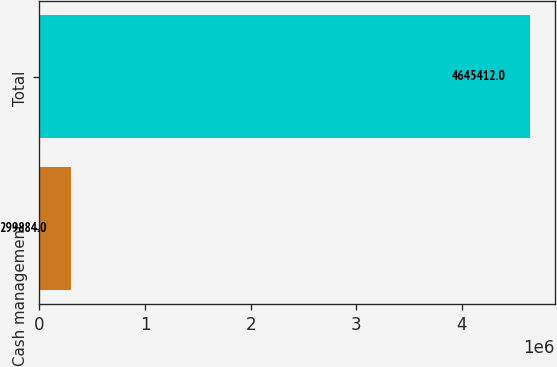Convert chart to OTSL. <chart><loc_0><loc_0><loc_500><loc_500><bar_chart><fcel>Cash management<fcel>Total<nl><fcel>299884<fcel>4.64541e+06<nl></chart> 